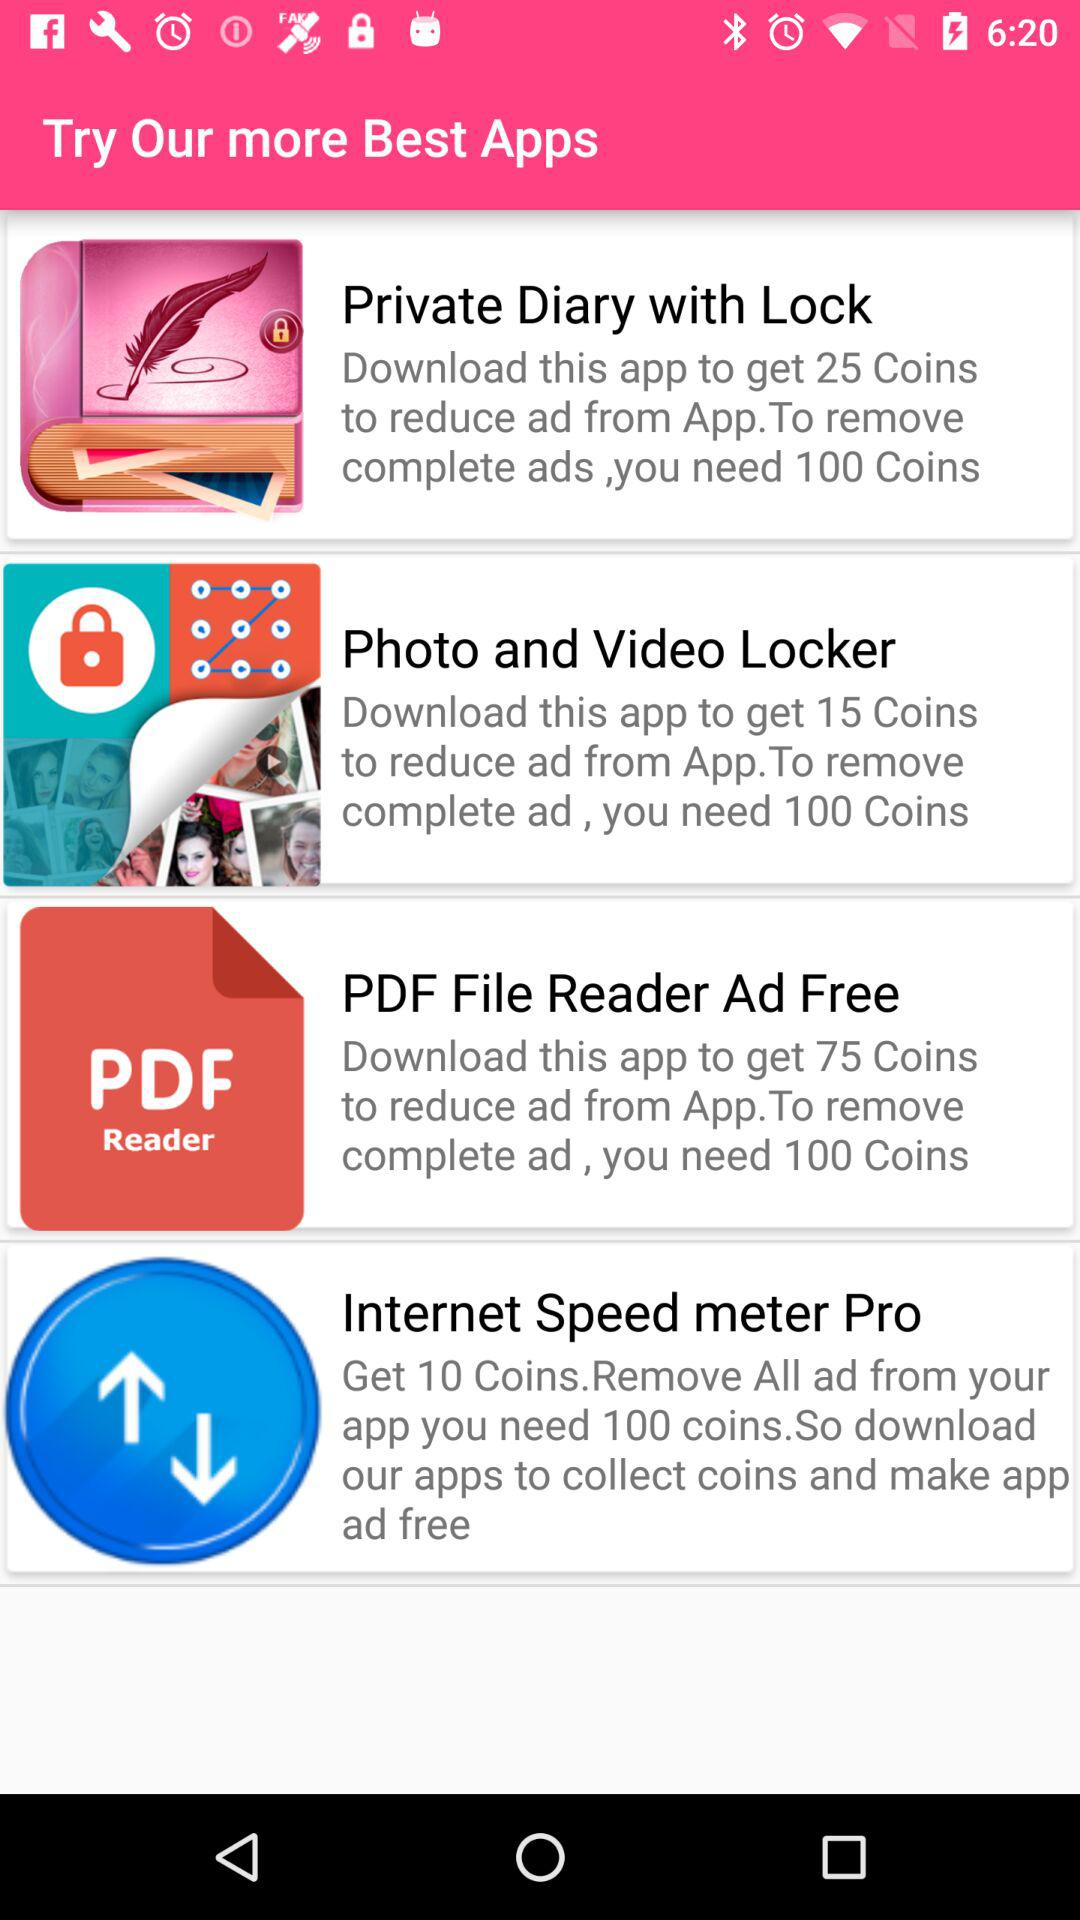Which app gives the most coins for downloading it?
Answer the question using a single word or phrase. PDF File Reader Ad Free 